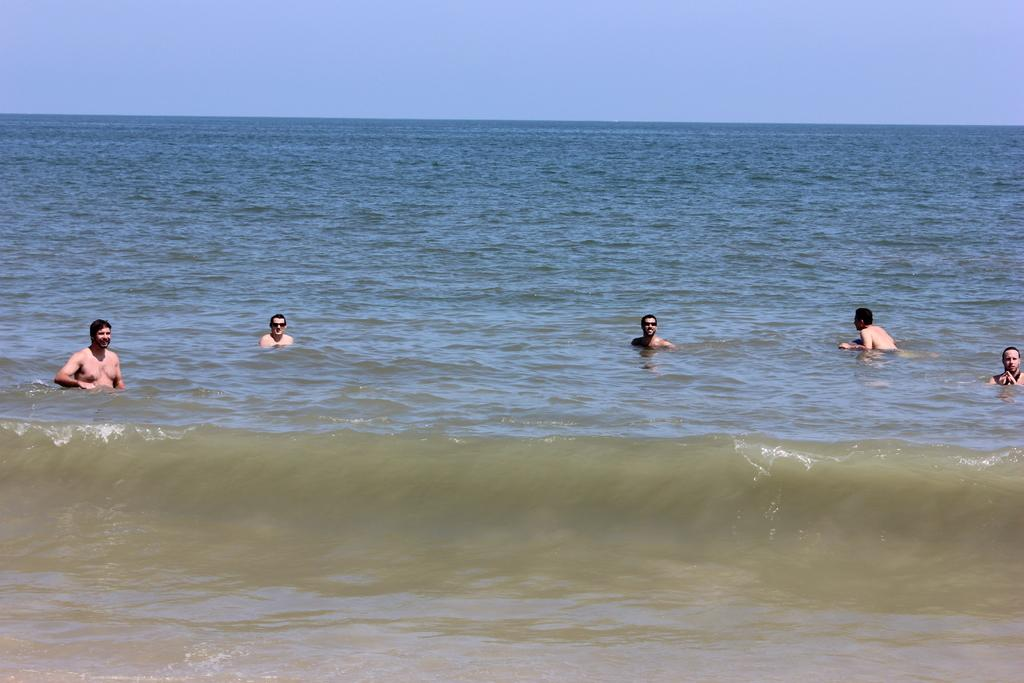What are the people in the image doing? There is a group of people in the water. What can be seen in the background of the image? The sky is visible behind the people. How many women are wearing sweaters in the image? There is no information about women or sweaters in the image, as it only shows a group of people in the water with the sky visible in the background. 